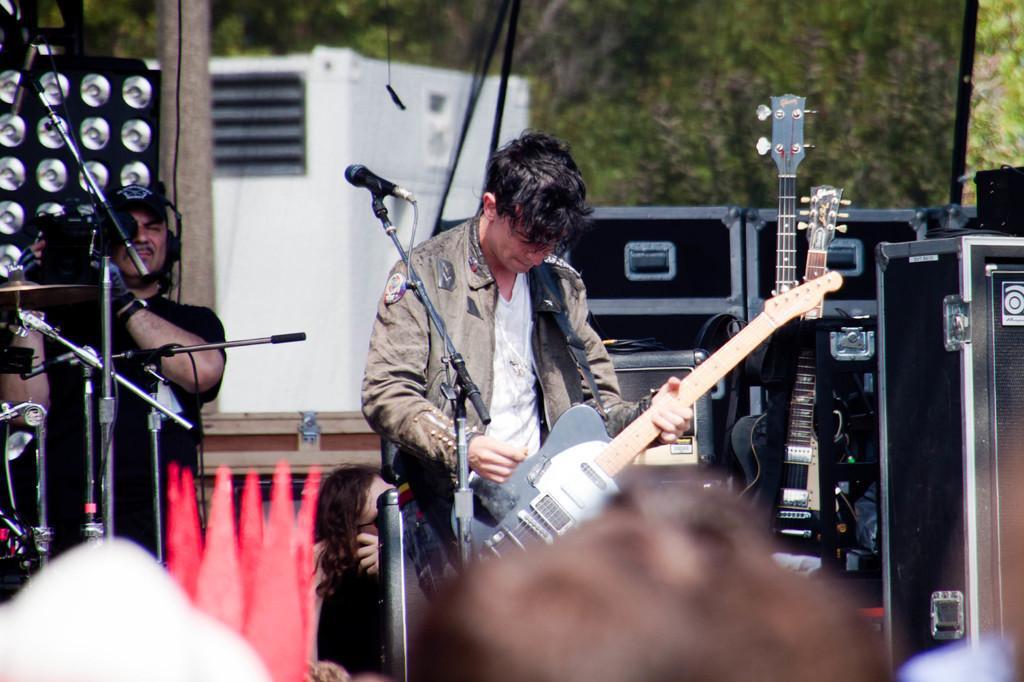How would you summarize this image in a sentence or two? In this picture i could see a person holding a guitar in his hands standing in front of mic. In the right side there are many speakers and boxes and in to the left a person holding a video camera and taking a videos. In the bottom of the picture a person's head can be seen and in the background trees can be seen. 